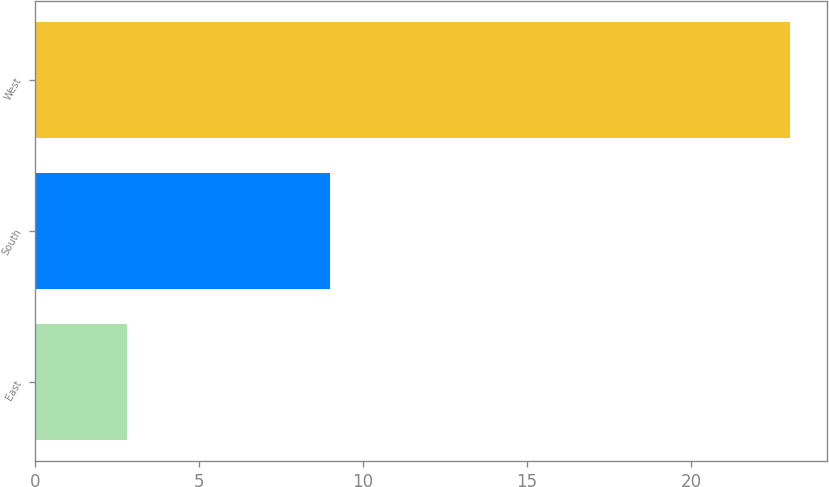Convert chart to OTSL. <chart><loc_0><loc_0><loc_500><loc_500><bar_chart><fcel>East<fcel>South<fcel>West<nl><fcel>2.81<fcel>9<fcel>23<nl></chart> 